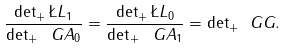<formula> <loc_0><loc_0><loc_500><loc_500>\frac { \det _ { + } \L L _ { 1 } } { \det _ { + } \ G A _ { 0 } } = \frac { \det _ { + } \L L _ { 0 } } { \det _ { + } \ G A _ { 1 } } = { \det } _ { + } \ G G .</formula> 